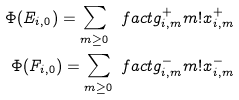<formula> <loc_0><loc_0><loc_500><loc_500>\Phi ( E _ { i , 0 } ) = \sum _ { m \geq 0 } \ f a c t { g ^ { + } _ { i , m } } { m ! } x ^ { + } _ { i , m } \\ \Phi ( F _ { i , 0 } ) = \sum _ { m \geq 0 } \ f a c t { g ^ { - } _ { i , m } } { m ! } x ^ { - } _ { i , m }</formula> 